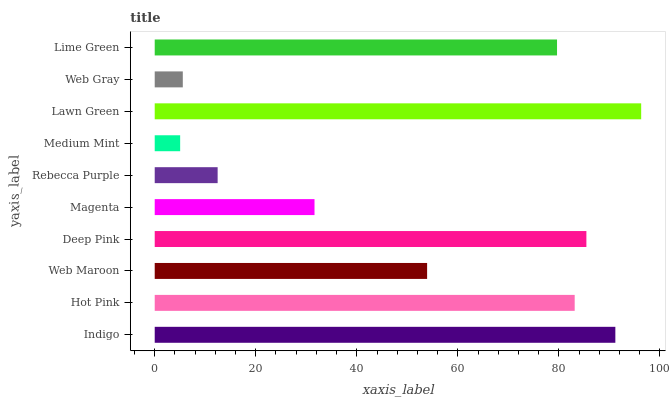Is Medium Mint the minimum?
Answer yes or no. Yes. Is Lawn Green the maximum?
Answer yes or no. Yes. Is Hot Pink the minimum?
Answer yes or no. No. Is Hot Pink the maximum?
Answer yes or no. No. Is Indigo greater than Hot Pink?
Answer yes or no. Yes. Is Hot Pink less than Indigo?
Answer yes or no. Yes. Is Hot Pink greater than Indigo?
Answer yes or no. No. Is Indigo less than Hot Pink?
Answer yes or no. No. Is Lime Green the high median?
Answer yes or no. Yes. Is Web Maroon the low median?
Answer yes or no. Yes. Is Hot Pink the high median?
Answer yes or no. No. Is Magenta the low median?
Answer yes or no. No. 